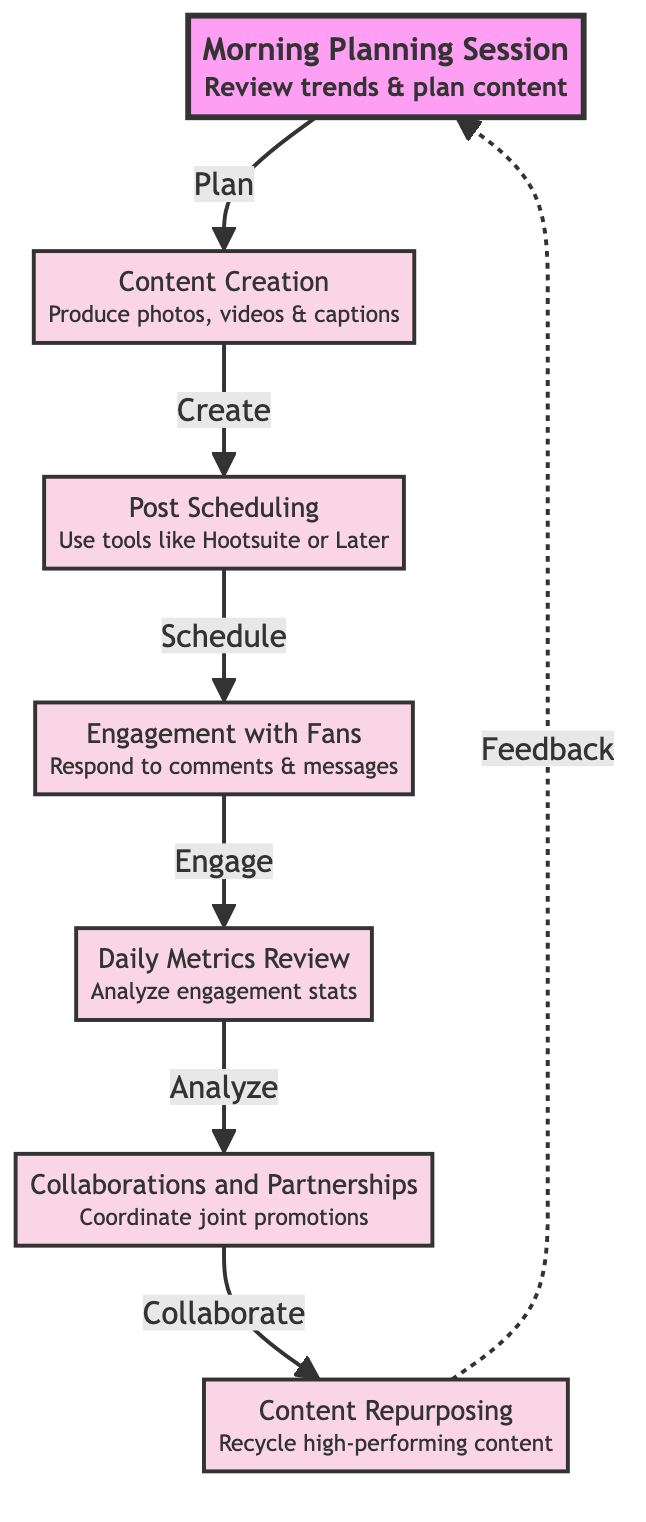What is the first step in the engagement strategy? The first step in the flow chart is the "Morning Planning Session," which is indicated as the starting point before any other activities happen.
Answer: Morning Planning Session How many main nodes are in the diagram? The diagram consists of seven main nodes, as indicated by the elements listed in the flow chart.
Answer: 7 What follows after the "Content Creation" step? The flow from "Content Creation" leads directly to "Post Scheduling," which is the next step in the engagement plan.
Answer: Post Scheduling Which step comes after engaging with fans? According to the flow chart, after "Engagement with Fans," the next action is "Daily Metrics Review."
Answer: Daily Metrics Review What type of relationship exists between "Collaborations and Partnerships" and "Content Repurposing"? The relationship is a dashed line indicating a feedback loop, meaning insights from collaborations contribute to content repurposing.
Answer: Feedback Which activity utilizes tools like Hootsuite or Later? The activity that uses tools like Hootsuite or Later is "Post Scheduling," making it clear that this step involves scheduling posts on social media.
Answer: Post Scheduling In the sequence of activities, what is the connection between "Daily Metrics Review" and "Collaborations and Partnerships"? The flow indicates that after analyzing engagement stats in "Daily Metrics Review," the subsequent activity involves coordinating for joint promotions in "Collaborations and Partnerships."
Answer: Collaborations and Partnerships What action is taken after "Post Scheduling"? After the "Post Scheduling" step, the flow chart demonstrates that the next action is "Engagement with Fans."
Answer: Engagement with Fans What do you do after analyzing engagement stats? After analyzing engagement stats, the strategy includes stepping into "Collaborations and Partnerships" for joint promotions.
Answer: Collaborations and Partnerships 